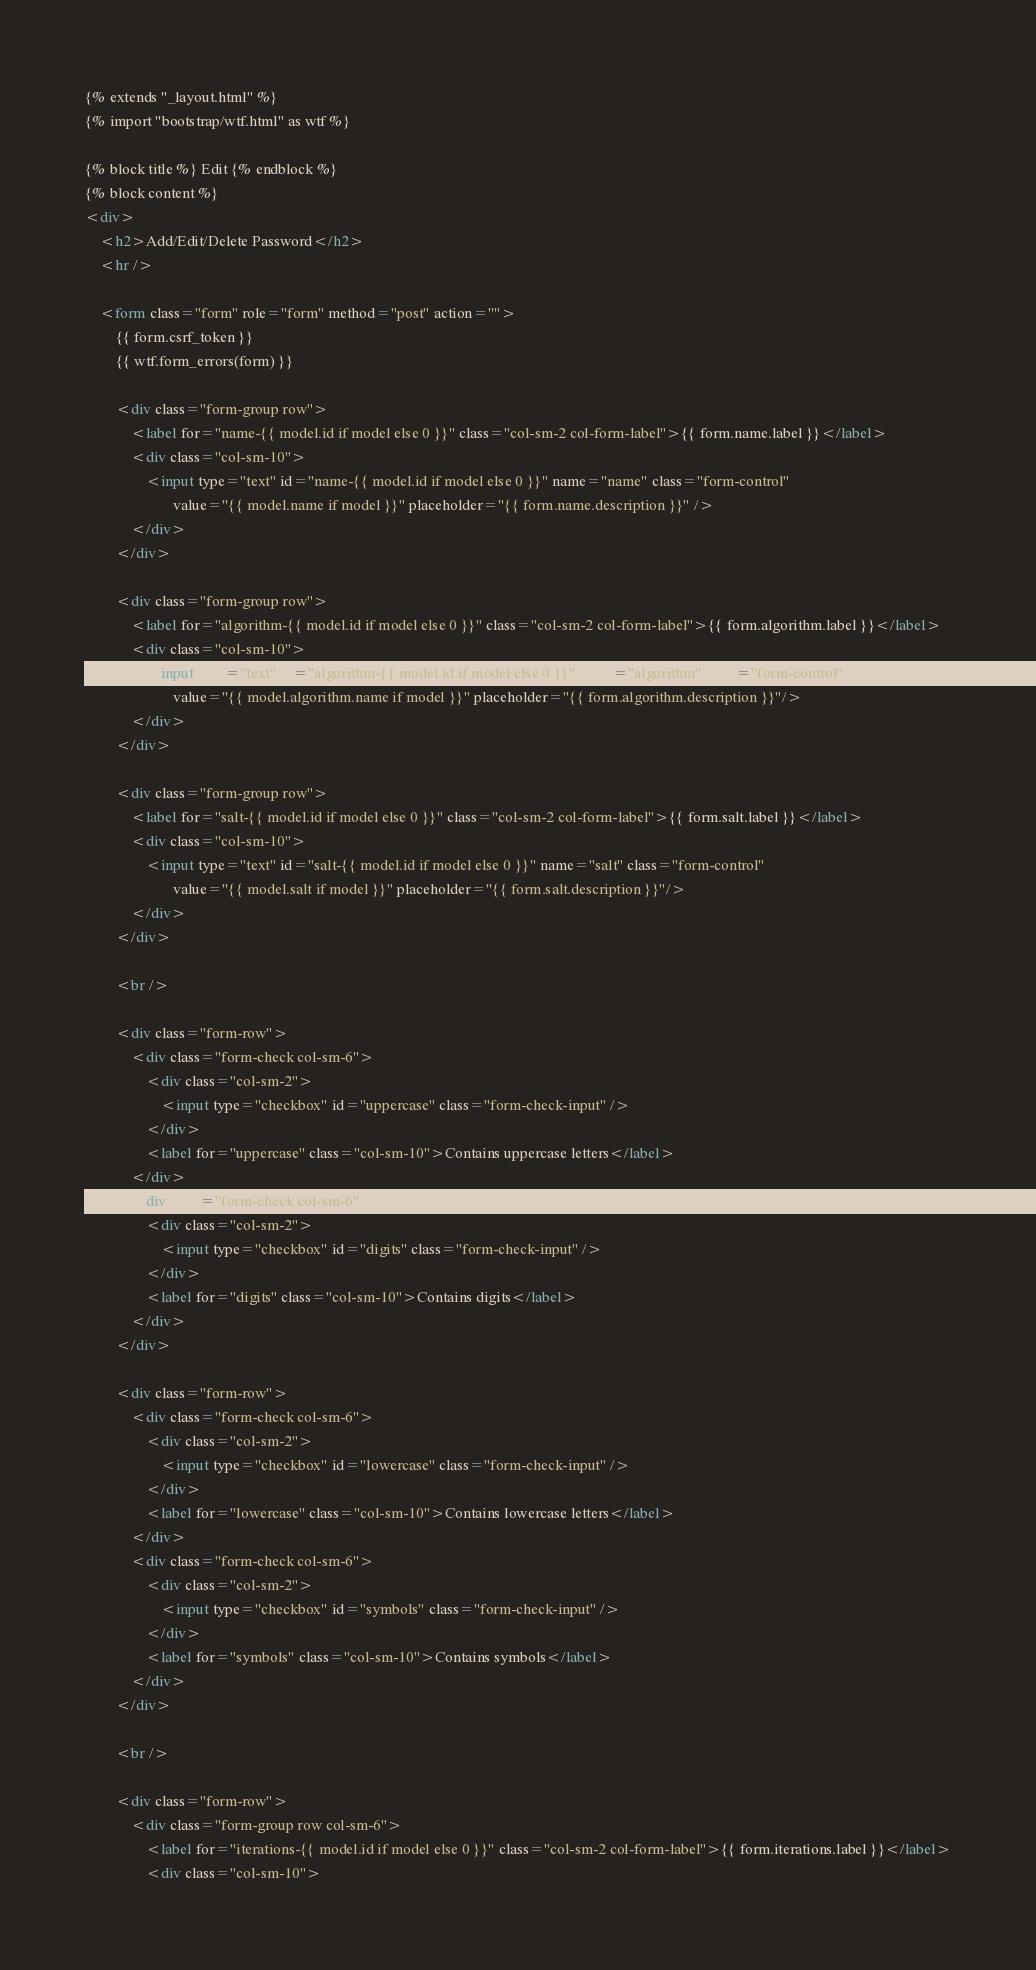Convert code to text. <code><loc_0><loc_0><loc_500><loc_500><_HTML_>{% extends "_layout.html" %}
{% import "bootstrap/wtf.html" as wtf %}

{% block title %} Edit {% endblock %}
{% block content %}
<div>
    <h2>Add/Edit/Delete Password</h2>
    <hr />

    <form class="form" role="form" method="post" action="">
        {{ form.csrf_token }}
        {{ wtf.form_errors(form) }}

        <div class="form-group row">
            <label for="name-{{ model.id if model else 0 }}" class="col-sm-2 col-form-label">{{ form.name.label }}</label>
            <div class="col-sm-10">
                <input type="text" id="name-{{ model.id if model else 0 }}" name="name" class="form-control"
                       value="{{ model.name if model }}" placeholder="{{ form.name.description }}" />
            </div>
        </div>

        <div class="form-group row">
            <label for="algorithm-{{ model.id if model else 0 }}" class="col-sm-2 col-form-label">{{ form.algorithm.label }}</label>
            <div class="col-sm-10">
                <input type="text" id="algorithm-{{ model.id if model else 0 }}" name="algorithm" class="form-control"
                       value="{{ model.algorithm.name if model }}" placeholder="{{ form.algorithm.description }}"/>
            </div>
        </div>

        <div class="form-group row">
            <label for="salt-{{ model.id if model else 0 }}" class="col-sm-2 col-form-label">{{ form.salt.label }}</label>
            <div class="col-sm-10">
                <input type="text" id="salt-{{ model.id if model else 0 }}" name="salt" class="form-control"
                       value="{{ model.salt if model }}" placeholder="{{ form.salt.description }}"/>
            </div>
        </div>

        <br />

        <div class="form-row">
            <div class="form-check col-sm-6">
                <div class="col-sm-2">
                    <input type="checkbox" id="uppercase" class="form-check-input" />
                </div>
                <label for="uppercase" class="col-sm-10">Contains uppercase letters</label>
            </div>
            <div class="form-check col-sm-6">
                <div class="col-sm-2">
                    <input type="checkbox" id="digits" class="form-check-input" />
                </div>
                <label for="digits" class="col-sm-10">Contains digits</label>
            </div>
        </div>

        <div class="form-row">
            <div class="form-check col-sm-6">
                <div class="col-sm-2">
                    <input type="checkbox" id="lowercase" class="form-check-input" />
                </div>
                <label for="lowercase" class="col-sm-10">Contains lowercase letters</label>
            </div>
            <div class="form-check col-sm-6">
                <div class="col-sm-2">
                    <input type="checkbox" id="symbols" class="form-check-input" />
                </div>
                <label for="symbols" class="col-sm-10">Contains symbols</label>
            </div>
        </div>

        <br />

        <div class="form-row">
            <div class="form-group row col-sm-6">
                <label for="iterations-{{ model.id if model else 0 }}" class="col-sm-2 col-form-label">{{ form.iterations.label }}</label>
                <div class="col-sm-10"></code> 